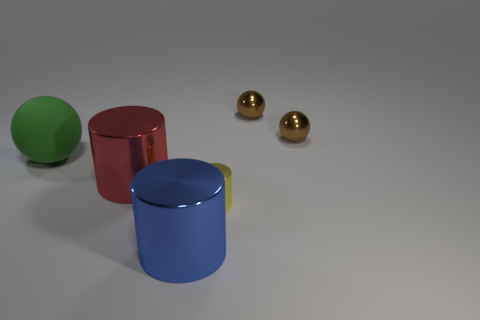Subtract all green spheres. How many spheres are left? 2 Add 2 small green rubber cubes. How many objects exist? 8 Subtract all red cylinders. How many cylinders are left? 2 Subtract all brown cylinders. How many brown balls are left? 2 Subtract 1 cylinders. How many cylinders are left? 2 Subtract all cyan cylinders. Subtract all cyan spheres. How many cylinders are left? 3 Add 4 big green rubber things. How many big green rubber things are left? 5 Add 1 small brown balls. How many small brown balls exist? 3 Subtract 0 blue blocks. How many objects are left? 6 Subtract all red metallic things. Subtract all small metal things. How many objects are left? 2 